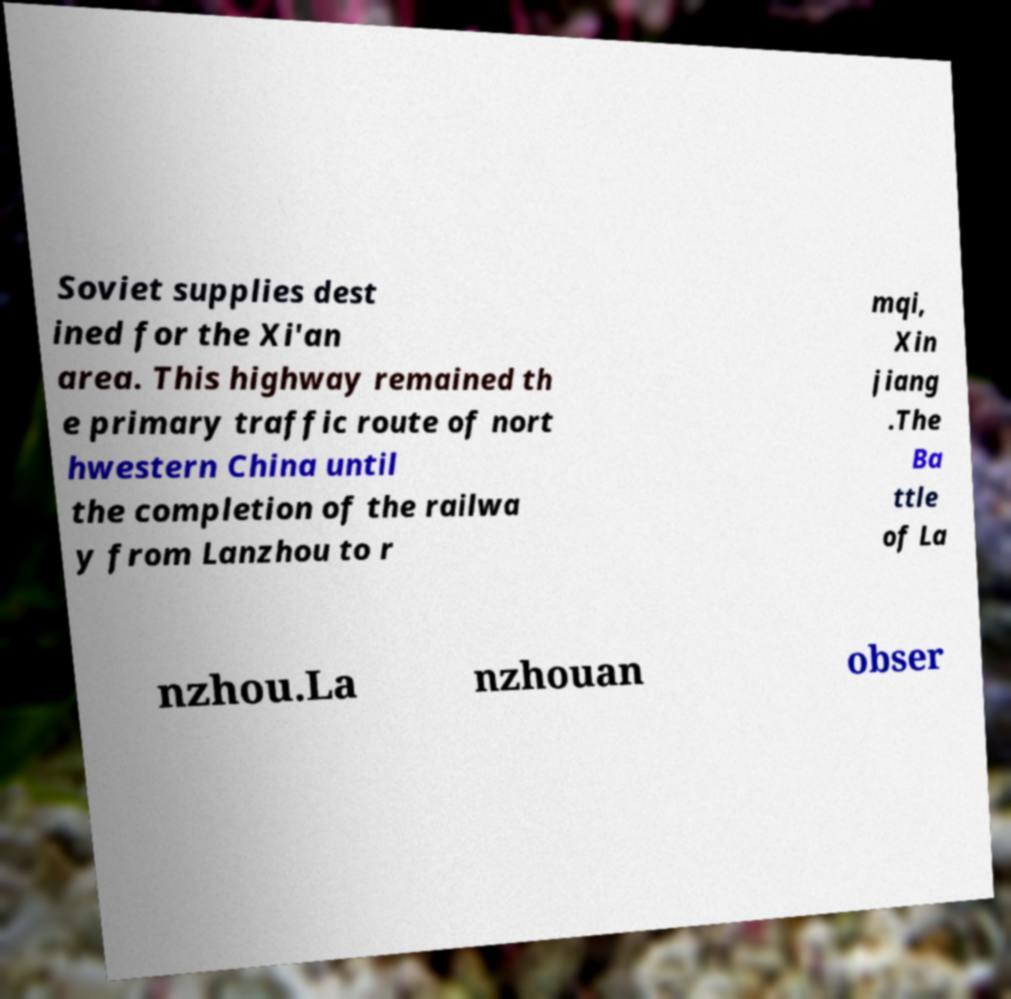Could you assist in decoding the text presented in this image and type it out clearly? Soviet supplies dest ined for the Xi'an area. This highway remained th e primary traffic route of nort hwestern China until the completion of the railwa y from Lanzhou to r mqi, Xin jiang .The Ba ttle of La nzhou.La nzhouan obser 